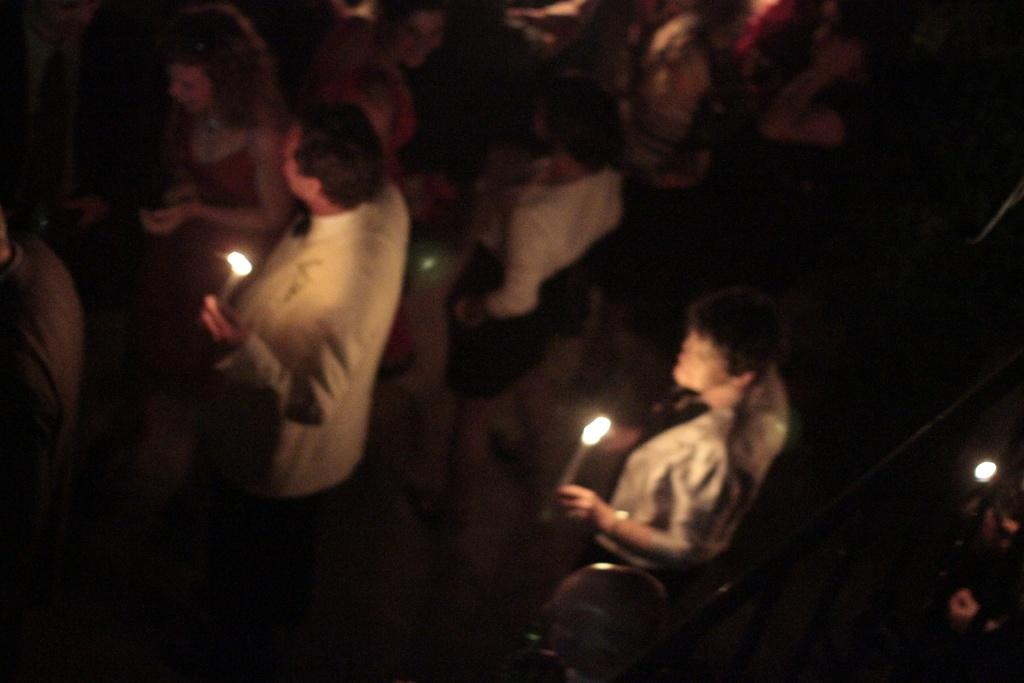How many people are in the image? There are people standing in the image. What are three of the people holding in their hands? Three persons are holding candles in their hands. What type of leg is visible in the image? There is no leg visible in the image; only people holding candles are present. What need is being fulfilled by the candles in the image? The purpose of the candles in the image cannot be determined without additional context. 